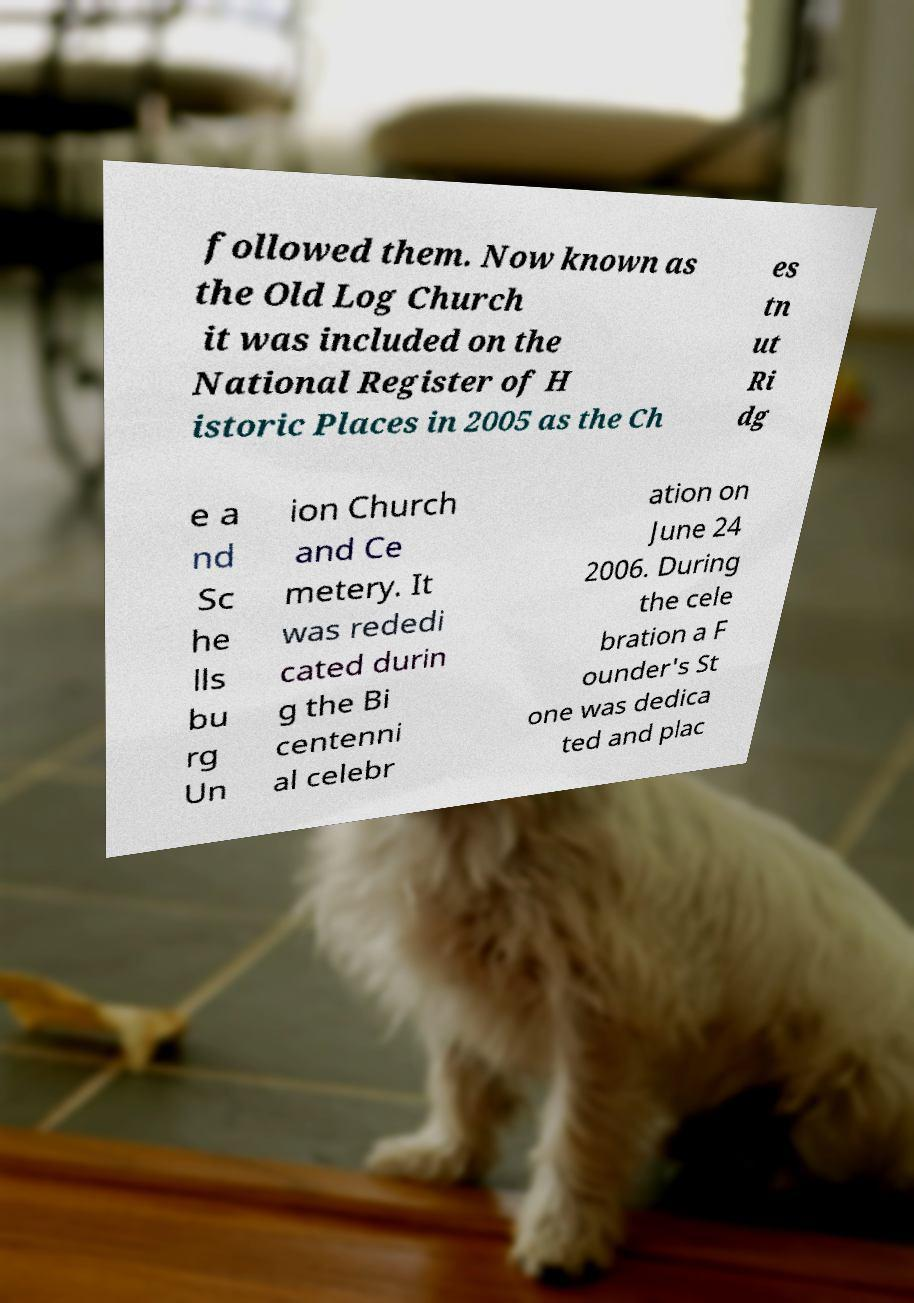Can you accurately transcribe the text from the provided image for me? followed them. Now known as the Old Log Church it was included on the National Register of H istoric Places in 2005 as the Ch es tn ut Ri dg e a nd Sc he lls bu rg Un ion Church and Ce metery. It was rededi cated durin g the Bi centenni al celebr ation on June 24 2006. During the cele bration a F ounder's St one was dedica ted and plac 